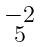Convert formula to latex. <formula><loc_0><loc_0><loc_500><loc_500>\begin{smallmatrix} - 2 \\ 5 \end{smallmatrix}</formula> 